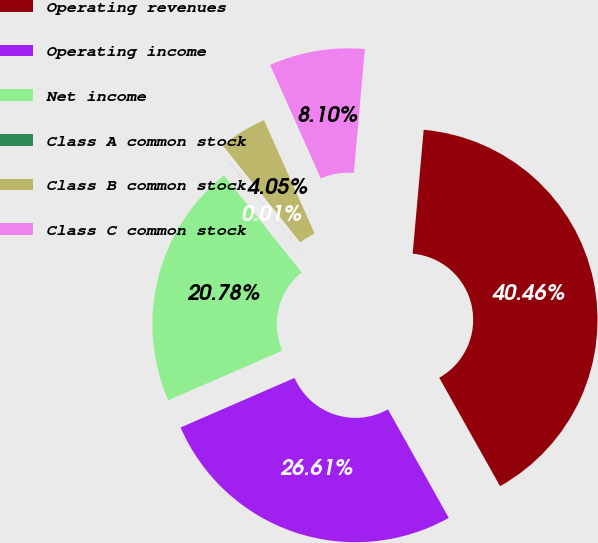Convert chart to OTSL. <chart><loc_0><loc_0><loc_500><loc_500><pie_chart><fcel>Operating revenues<fcel>Operating income<fcel>Net income<fcel>Class A common stock<fcel>Class B common stock<fcel>Class C common stock<nl><fcel>40.46%<fcel>26.61%<fcel>20.78%<fcel>0.01%<fcel>4.05%<fcel>8.1%<nl></chart> 